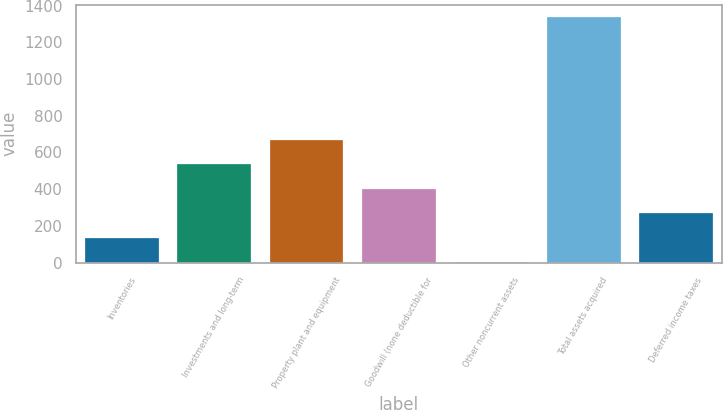Convert chart to OTSL. <chart><loc_0><loc_0><loc_500><loc_500><bar_chart><fcel>Inventories<fcel>Investments and long-term<fcel>Property plant and equipment<fcel>Goodwill (none deductible for<fcel>Other noncurrent assets<fcel>Total assets acquired<fcel>Deferred income taxes<nl><fcel>136.3<fcel>536.2<fcel>669.5<fcel>402.9<fcel>3<fcel>1336<fcel>269.6<nl></chart> 